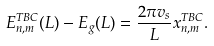<formula> <loc_0><loc_0><loc_500><loc_500>E _ { n , m } ^ { T B C } ( L ) - E _ { g } ( L ) = \frac { 2 \pi v _ { s } } { L } x _ { n , m } ^ { T B C } .</formula> 